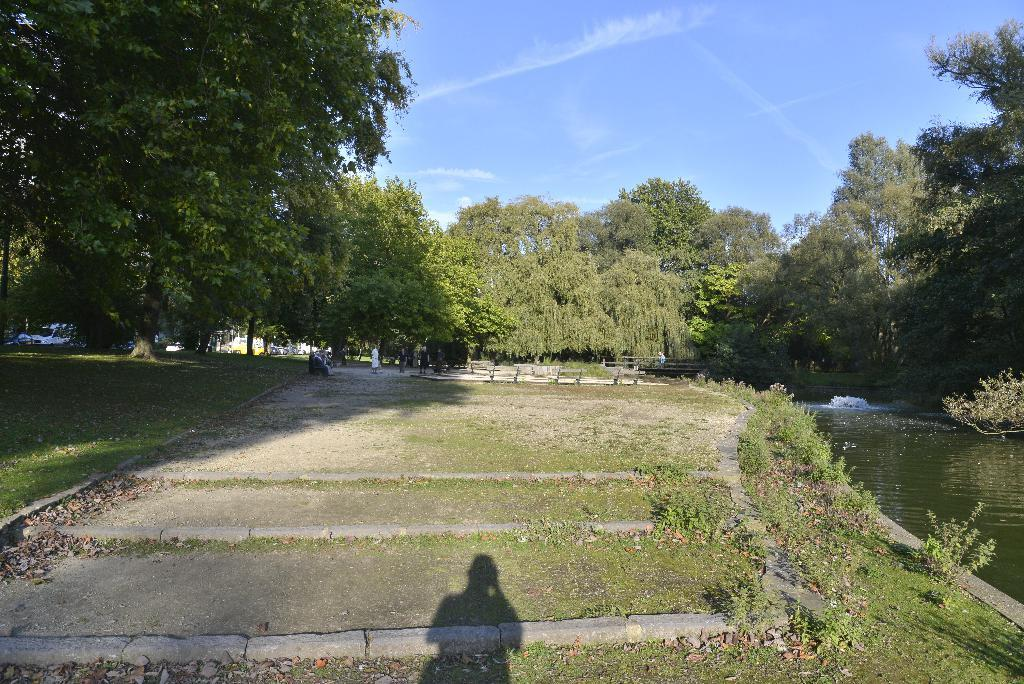What type of vegetation can be seen in the image? There are trees and plants in the image. What type of seating is available in the image? There are benches in the image. What is on the ground in the image? There is grass on the ground in the image. What is the shadow in the image a shadow of? The shadow in the image is a shadow of a human. What is visible in the image besides vegetation and seating? There is water visible in the image. How would you describe the sky in the image? The sky is blue and cloudy in the image. Can you tell me how many books are on the library shelf in the image? There is no library or shelf visible in the image; it features trees, plants, benches, grass, a shadow, water, and a blue and cloudy sky. What type of root is growing near the water in the image? There is no root visible in the image; it features trees, plants, benches, grass, a shadow, water, and a blue and cloudy sky. 